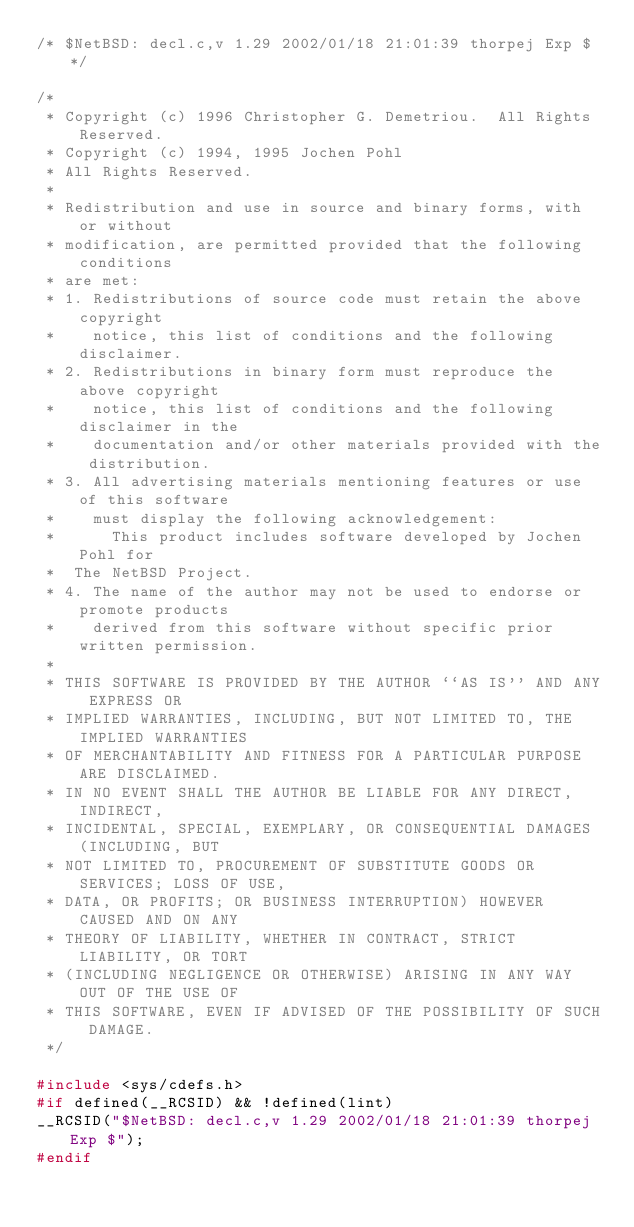<code> <loc_0><loc_0><loc_500><loc_500><_C_>/* $NetBSD: decl.c,v 1.29 2002/01/18 21:01:39 thorpej Exp $ */

/*
 * Copyright (c) 1996 Christopher G. Demetriou.  All Rights Reserved.
 * Copyright (c) 1994, 1995 Jochen Pohl
 * All Rights Reserved.
 *
 * Redistribution and use in source and binary forms, with or without
 * modification, are permitted provided that the following conditions
 * are met:
 * 1. Redistributions of source code must retain the above copyright
 *    notice, this list of conditions and the following disclaimer.
 * 2. Redistributions in binary form must reproduce the above copyright
 *    notice, this list of conditions and the following disclaimer in the
 *    documentation and/or other materials provided with the distribution.
 * 3. All advertising materials mentioning features or use of this software
 *    must display the following acknowledgement:
 *      This product includes software developed by Jochen Pohl for
 *	The NetBSD Project.
 * 4. The name of the author may not be used to endorse or promote products
 *    derived from this software without specific prior written permission.
 *
 * THIS SOFTWARE IS PROVIDED BY THE AUTHOR ``AS IS'' AND ANY EXPRESS OR
 * IMPLIED WARRANTIES, INCLUDING, BUT NOT LIMITED TO, THE IMPLIED WARRANTIES
 * OF MERCHANTABILITY AND FITNESS FOR A PARTICULAR PURPOSE ARE DISCLAIMED.
 * IN NO EVENT SHALL THE AUTHOR BE LIABLE FOR ANY DIRECT, INDIRECT,
 * INCIDENTAL, SPECIAL, EXEMPLARY, OR CONSEQUENTIAL DAMAGES (INCLUDING, BUT
 * NOT LIMITED TO, PROCUREMENT OF SUBSTITUTE GOODS OR SERVICES; LOSS OF USE,
 * DATA, OR PROFITS; OR BUSINESS INTERRUPTION) HOWEVER CAUSED AND ON ANY
 * THEORY OF LIABILITY, WHETHER IN CONTRACT, STRICT LIABILITY, OR TORT
 * (INCLUDING NEGLIGENCE OR OTHERWISE) ARISING IN ANY WAY OUT OF THE USE OF
 * THIS SOFTWARE, EVEN IF ADVISED OF THE POSSIBILITY OF SUCH DAMAGE.
 */

#include <sys/cdefs.h>
#if defined(__RCSID) && !defined(lint)
__RCSID("$NetBSD: decl.c,v 1.29 2002/01/18 21:01:39 thorpej Exp $");
#endif</code> 